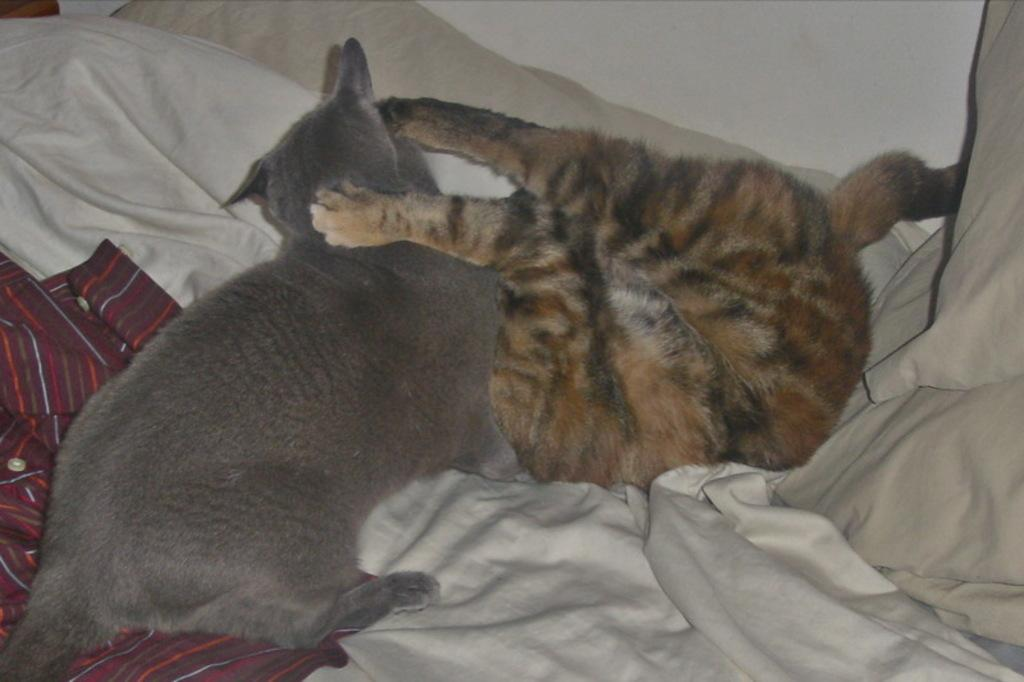How many cats are in the image? There are two cats in the image. What are the cats doing in the image? The cats are laying down. What is at the bottom of the image? There is a bed sheet at the bottom of the image. What type of fabric is visible in the image? There is a cloth visible in the image. What can be seen in the background of the image? There is a wall in the background of the image. What type of tomatoes can be seen growing on the wall in the image? There are no tomatoes visible in the image, and the wall does not have any plants growing on it. 